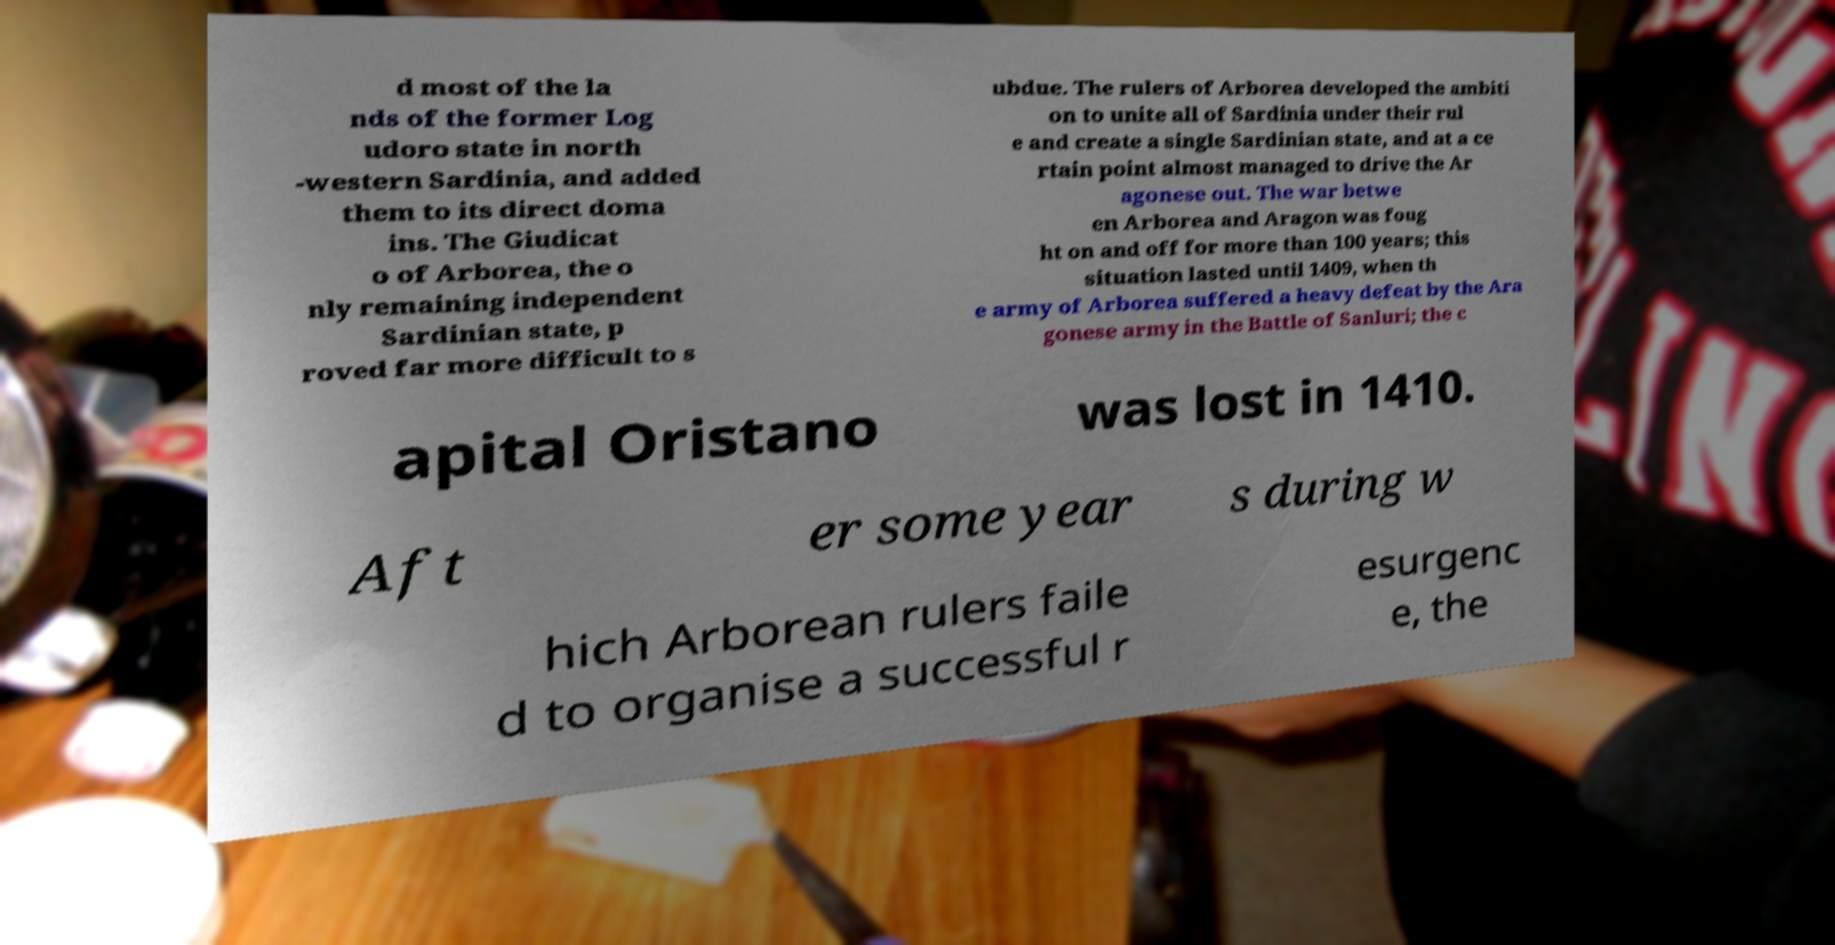What messages or text are displayed in this image? I need them in a readable, typed format. d most of the la nds of the former Log udoro state in north -western Sardinia, and added them to its direct doma ins. The Giudicat o of Arborea, the o nly remaining independent Sardinian state, p roved far more difficult to s ubdue. The rulers of Arborea developed the ambiti on to unite all of Sardinia under their rul e and create a single Sardinian state, and at a ce rtain point almost managed to drive the Ar agonese out. The war betwe en Arborea and Aragon was foug ht on and off for more than 100 years; this situation lasted until 1409, when th e army of Arborea suffered a heavy defeat by the Ara gonese army in the Battle of Sanluri; the c apital Oristano was lost in 1410. Aft er some year s during w hich Arborean rulers faile d to organise a successful r esurgenc e, the 